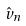Convert formula to latex. <formula><loc_0><loc_0><loc_500><loc_500>\hat { v } _ { n }</formula> 